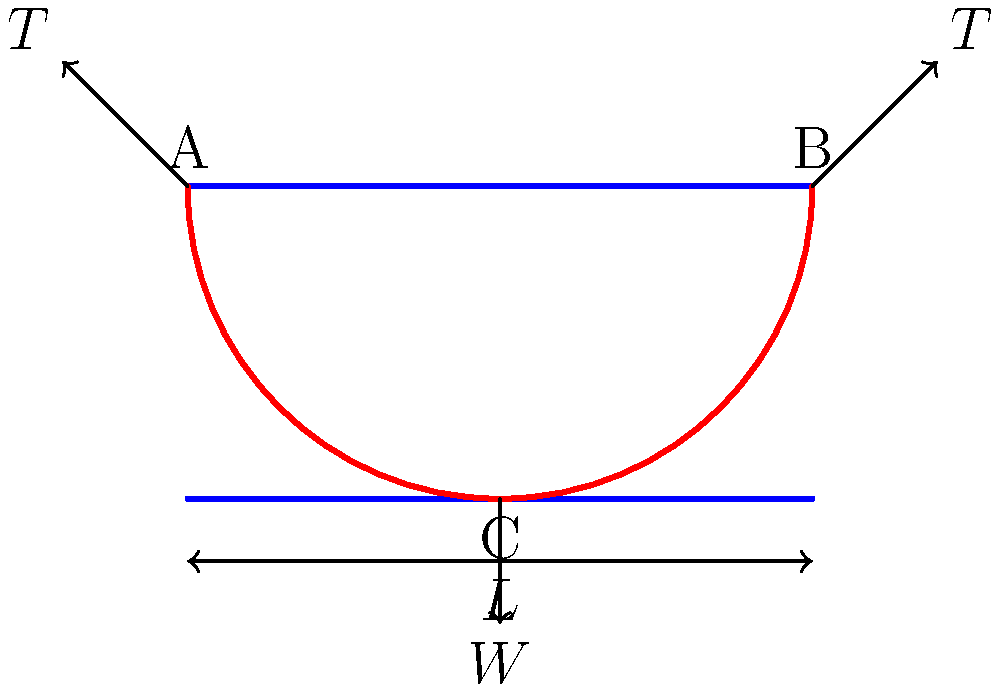In a suspension bridge design, the main cable has a tension $T$ of 5000 kN at each end, and the total weight $W$ of the bridge deck is 8000 kN. If the span $L$ of the bridge is 200 m and the cable sag at the center is 20 m, what is the horizontal component of the cable tension? To solve this problem, we'll use concepts from statics and bridge engineering. Let's approach this step-by-step:

1) In a suspension bridge, the cable forms a parabolic shape. The horizontal component of the cable tension ($H$) is constant along the cable.

2) At the center of the span (point C), we can write the vertical force equilibrium:
   
   $$2T_v = W$$
   
   where $T_v$ is the vertical component of the cable tension at the support.

3) The ratio of the sag ($f$) to the span ($L$) is related to the tension components:
   
   $$\frac{f}{L} = \frac{W}{8H}$$

4) We know:
   - $T = 5000$ kN
   - $W = 8000$ kN
   - $L = 200$ m
   - $f = 20$ m

5) Substituting these values into the sag-span ratio equation:
   
   $$\frac{20}{200} = \frac{8000}{8H}$$

6) Simplifying:
   
   $$\frac{1}{10} = \frac{1000}{H}$$

7) Solving for $H$:
   
   $$H = 1000 \times 10 = 10000$$ kN

Therefore, the horizontal component of the cable tension is 10000 kN.
Answer: 10000 kN 